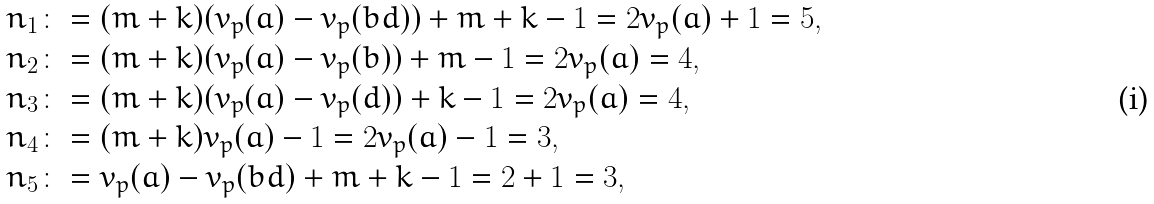Convert formula to latex. <formula><loc_0><loc_0><loc_500><loc_500>n _ { 1 } & \colon = ( m + k ) ( v _ { p } ( a ) - v _ { p } ( b d ) ) + m + k - 1 = 2 v _ { p } ( a ) + 1 = 5 , \\ n _ { 2 } & \colon = ( m + k ) ( v _ { p } ( a ) - v _ { p } ( b ) ) + m - 1 = 2 v _ { p } ( a ) = 4 , \\ n _ { 3 } & \colon = ( m + k ) ( v _ { p } ( a ) - v _ { p } ( d ) ) + k - 1 = 2 v _ { p } ( a ) = 4 , \\ n _ { 4 } & \colon = ( m + k ) v _ { p } ( a ) - 1 = 2 v _ { p } ( a ) - 1 = 3 , \\ n _ { 5 } & \colon = v _ { p } ( a ) - v _ { p } ( b d ) + m + k - 1 = 2 + 1 = 3 ,</formula> 